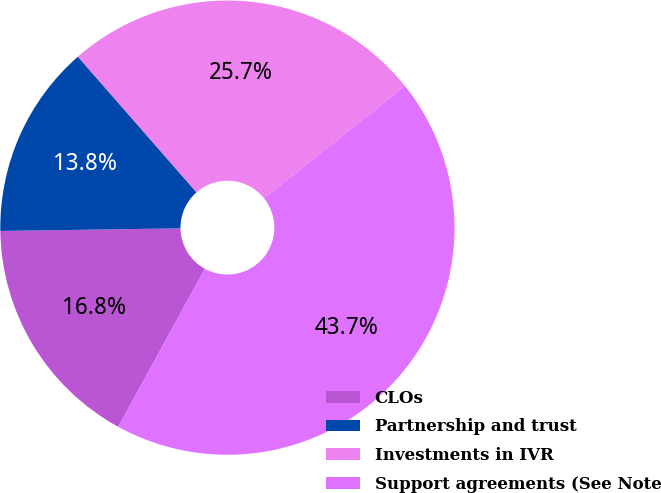<chart> <loc_0><loc_0><loc_500><loc_500><pie_chart><fcel>CLOs<fcel>Partnership and trust<fcel>Investments in IVR<fcel>Support agreements (See Note<nl><fcel>16.79%<fcel>13.8%<fcel>25.71%<fcel>43.71%<nl></chart> 